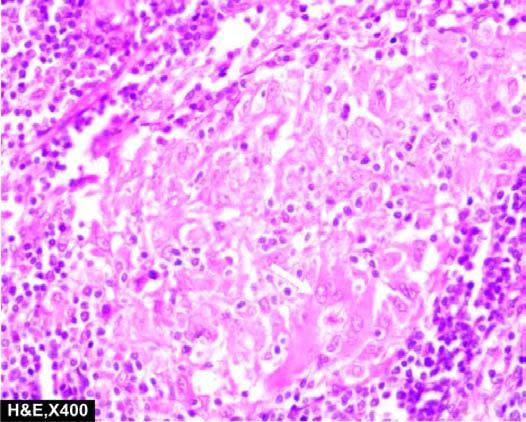s congo red staining also seen in the photomicrograph?
Answer the question using a single word or phrase. No 